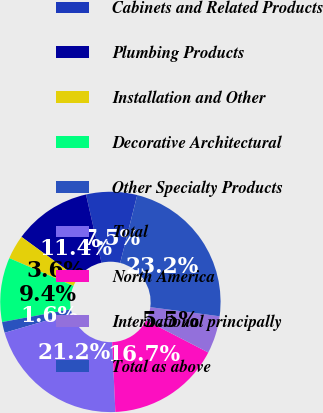Convert chart to OTSL. <chart><loc_0><loc_0><loc_500><loc_500><pie_chart><fcel>Cabinets and Related Products<fcel>Plumbing Products<fcel>Installation and Other<fcel>Decorative Architectural<fcel>Other Specialty Products<fcel>Total<fcel>North America<fcel>International principally<fcel>Total as above<nl><fcel>7.47%<fcel>11.39%<fcel>3.55%<fcel>9.43%<fcel>1.59%<fcel>21.2%<fcel>16.69%<fcel>5.51%<fcel>23.16%<nl></chart> 